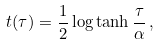<formula> <loc_0><loc_0><loc_500><loc_500>t ( \tau ) = \frac { 1 } { 2 } \log \tanh \frac { \tau } { \alpha } \, ,</formula> 